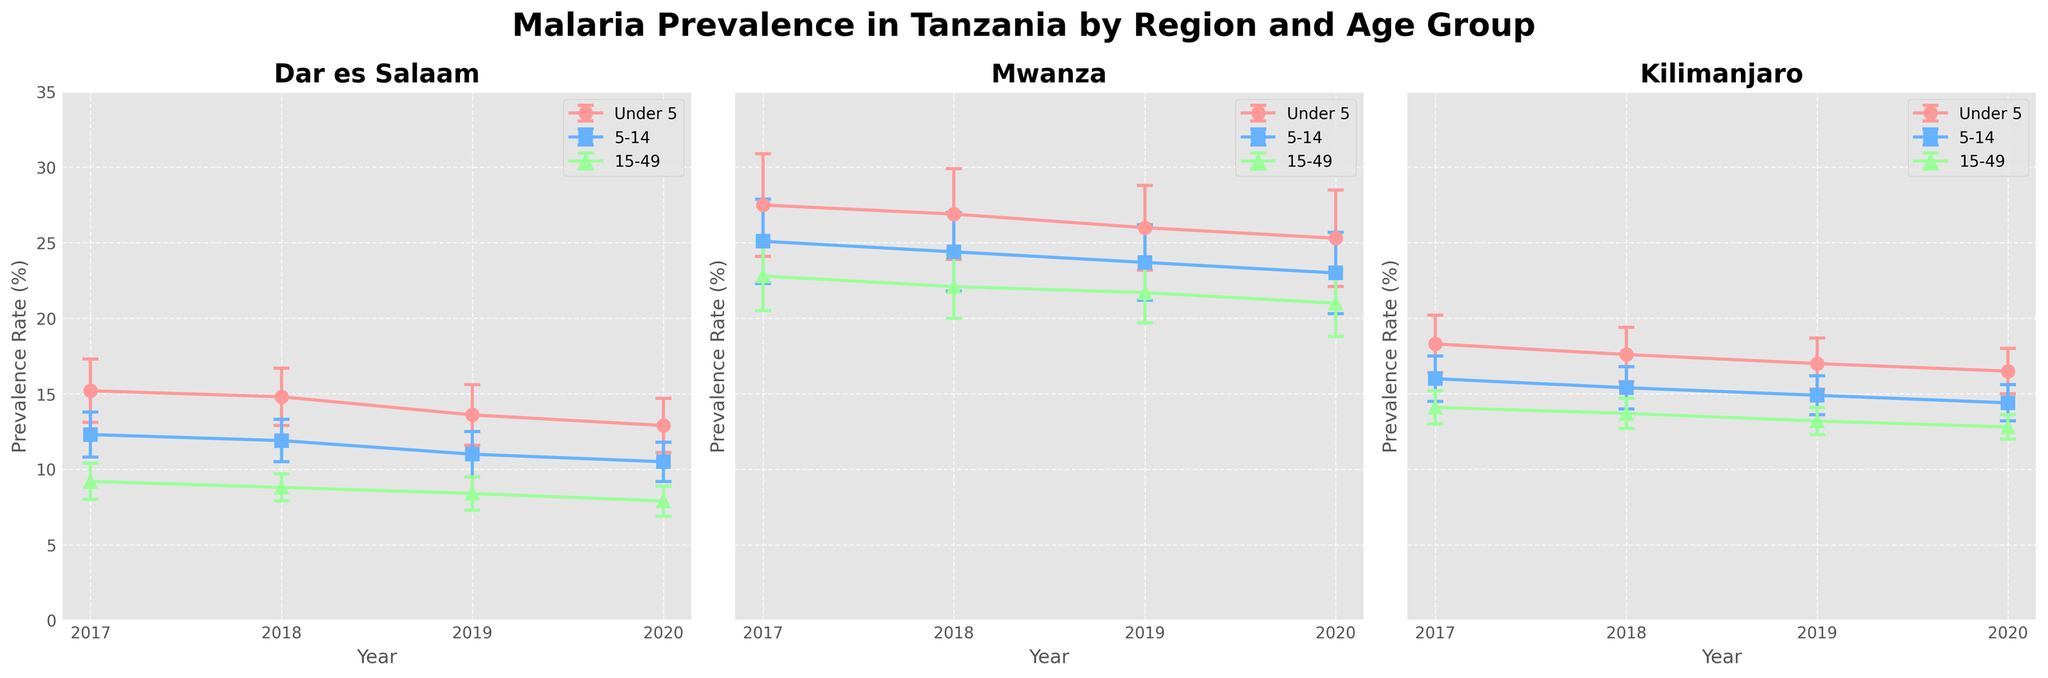Which region has the highest prevalence rate for the "Under 5" age group in 2017? We examine the plots for each region and locate the "Under 5" age group data point for 2017. We then identify which region has the highest value on its y-axis.
Answer: Mwanza What is the overall trend in the prevalence rate for the "15-49" age group from 2017 to 2020 in Dar es Salaam? We check the "15-49" age group line in the Dar es Salaam subplot and observe the year-wise change. The line shows a decreasing trend over the years.
Answer: Decreasing For the "5-14" age group in Kilimanjaro, which year has the smallest prevalence rate? We locate the "5-14" age group data points in the Kilimanjaro subplot and compare the values for each year. The smallest prevalence rate is in 2020.
Answer: 2020 Comparing the "Under 5" age group, which region has the smallest error bars in 2020, and how does it compare to the other regions? We look at the "Under 5" age group data points for 2020 in each subplot, focus on the error bars, and identify the region with the smallest error bars. Kilimanjaro has the smallest error bars compared to Dar es Salaam and Mwanza.
Answer: Kilimanjaro, smallest Which age group in Mwanza shows the least reduction in prevalence rate from 2017 to 2020? Observe each age group's data points in Mwanza's subplot. Calculate the reduction by subtracting the prevalence rate in 2020 from the 2017 rate for each age group. The "15-49" age group shows the least reduction.
Answer: 15-49 How does the prevalence rate in 2019 for "5-14" age group in Kilimanjaro compare to that in Dar es Salaam? Find the prevalence rate for "5-14" age group in both Kilimanjaro and Dar es Salaam for 2019. Kilimanjaro has a higher prevalence rate compared to Dar es Salaam.
Answer: Kilimanjaro is higher What is the average prevalence rate in 2018 for all age groups combined in Dar es Salaam? Calculate the average of the prevalence rates for all three age groups in Dar es Salaam for the year 2018. (14.8 + 11.9 + 8.8) / 3 = 11.83
Answer: 11.83 Which region has the highest prevalence rate for the "5-14" age group in 2020 and what is the value? Locate the "5-14" age group data points for 2020 in each subplot and identify which region has the highest value on the y-axis. Mwanza has the highest prevalence with a value of 23.0%.
Answer: Mwanza, 23.0% Comparing all the age groups, which one showed the largest decrease in prevalence rate in Mwanza from 2017 to 2020? Find the difference in prevalence rate for each age group from 2017 to 2020 in Mwanza. Subtract the 2020 rate from the 2017 rate for each group and determine the largest decrease. "Under 5" showed the largest decrease.
Answer: Under 5 In which year did the "Under 5" group in Kilimanjaro see the highest prevalence rate, and what was the error percentage? Check the Kilimanjaro subplot for the "Under 5" age group. Determine the year with the highest prevalence rate and note the error percentage associated with it. The highest rate was in 2017 with an error of 1.9%.
Answer: 2017, 1.9% 